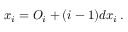Convert formula to latex. <formula><loc_0><loc_0><loc_500><loc_500>x _ { i } = O _ { i } + ( i - 1 ) d x _ { i } \, .</formula> 